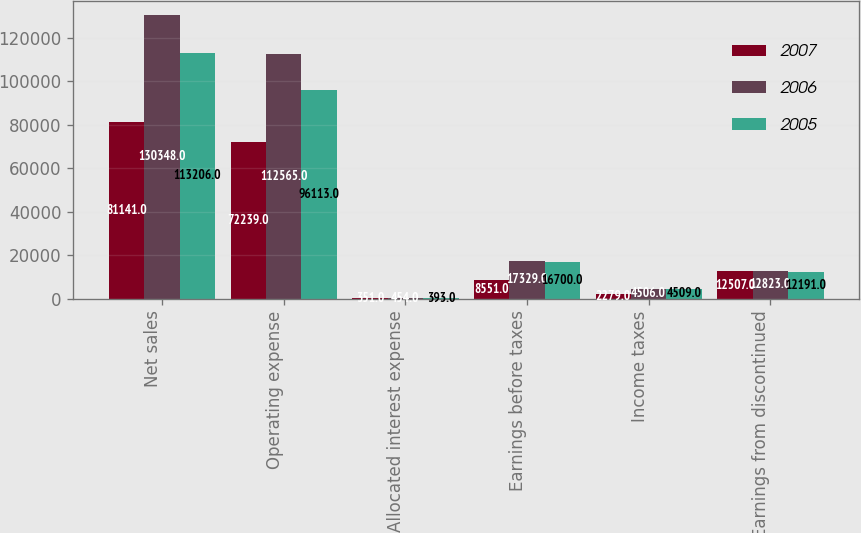<chart> <loc_0><loc_0><loc_500><loc_500><stacked_bar_chart><ecel><fcel>Net sales<fcel>Operating expense<fcel>Allocated interest expense<fcel>Earnings before taxes<fcel>Income taxes<fcel>Earnings from discontinued<nl><fcel>2007<fcel>81141<fcel>72239<fcel>351<fcel>8551<fcel>2279<fcel>12507<nl><fcel>2006<fcel>130348<fcel>112565<fcel>454<fcel>17329<fcel>4506<fcel>12823<nl><fcel>2005<fcel>113206<fcel>96113<fcel>393<fcel>16700<fcel>4509<fcel>12191<nl></chart> 